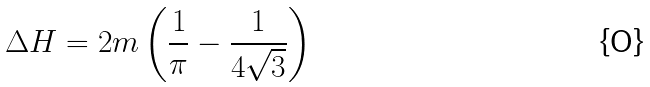Convert formula to latex. <formula><loc_0><loc_0><loc_500><loc_500>\Delta H = 2 m \left ( \frac { 1 } { \pi } - \frac { 1 } { 4 \sqrt { 3 } } \right )</formula> 